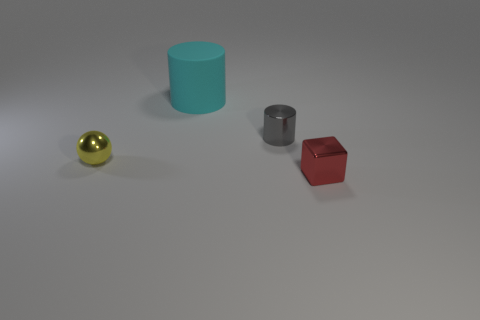Which object stands out the most, and why do you think that is? The golden sphere stands out due to its shiny, reflective surface and distinct color which contrasts with the matte textures and more subdued colors of the other objects. 